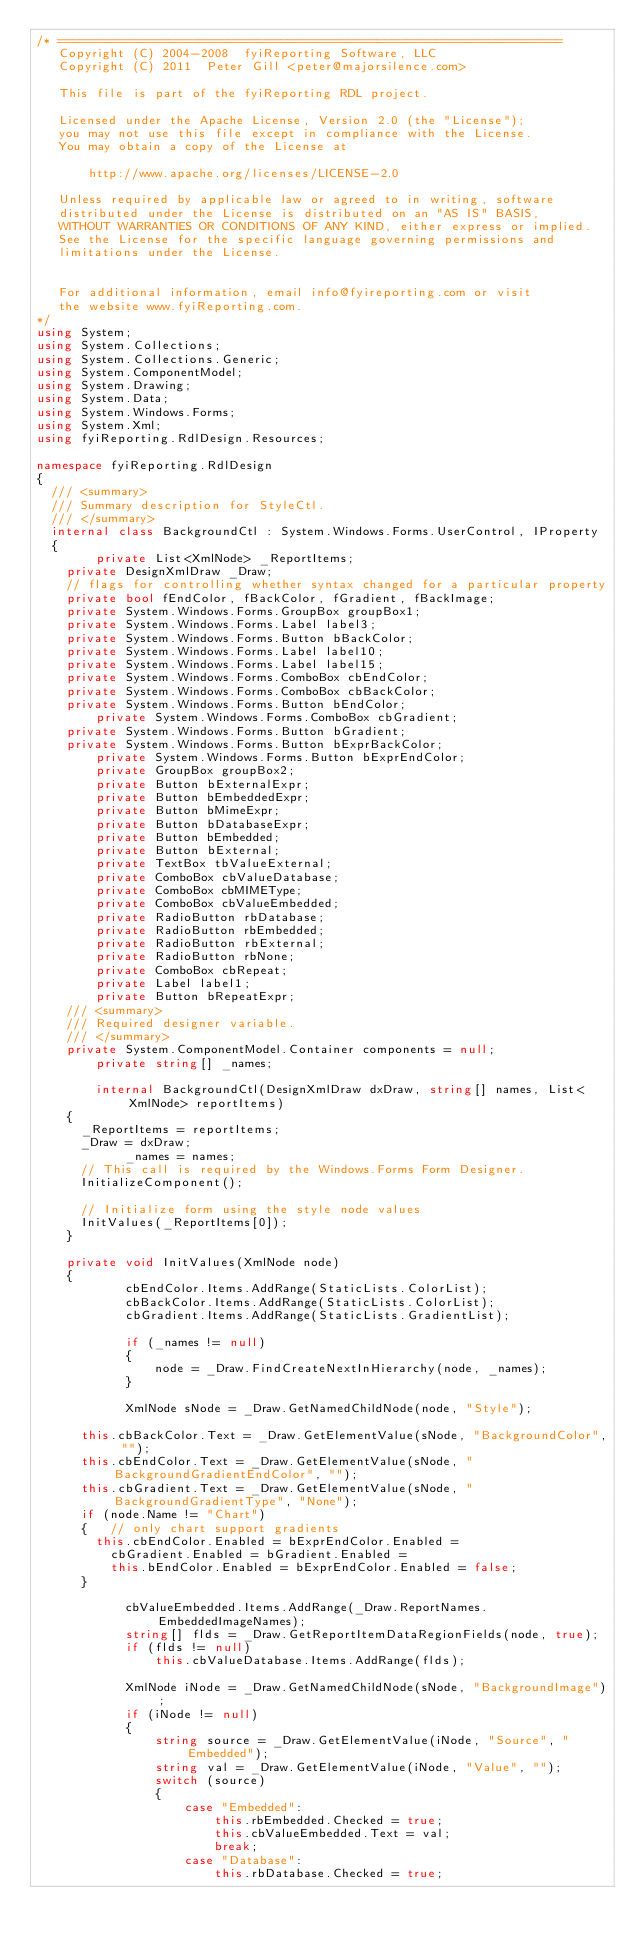<code> <loc_0><loc_0><loc_500><loc_500><_C#_>/* ====================================================================
   Copyright (C) 2004-2008  fyiReporting Software, LLC
   Copyright (C) 2011  Peter Gill <peter@majorsilence.com>

   This file is part of the fyiReporting RDL project.
	
   Licensed under the Apache License, Version 2.0 (the "License");
   you may not use this file except in compliance with the License.
   You may obtain a copy of the License at

       http://www.apache.org/licenses/LICENSE-2.0

   Unless required by applicable law or agreed to in writing, software
   distributed under the License is distributed on an "AS IS" BASIS,
   WITHOUT WARRANTIES OR CONDITIONS OF ANY KIND, either express or implied.
   See the License for the specific language governing permissions and
   limitations under the License.


   For additional information, email info@fyireporting.com or visit
   the website www.fyiReporting.com.
*/
using System;
using System.Collections;
using System.Collections.Generic;
using System.ComponentModel;
using System.Drawing;
using System.Data;
using System.Windows.Forms;
using System.Xml;
using fyiReporting.RdlDesign.Resources;

namespace fyiReporting.RdlDesign
{
	/// <summary>
	/// Summary description for StyleCtl.
	/// </summary>
	internal class BackgroundCtl : System.Windows.Forms.UserControl, IProperty
	{
        private List<XmlNode> _ReportItems;
		private DesignXmlDraw _Draw;
		// flags for controlling whether syntax changed for a particular property
		private bool fEndColor, fBackColor, fGradient, fBackImage;
		private System.Windows.Forms.GroupBox groupBox1;
		private System.Windows.Forms.Label label3;
		private System.Windows.Forms.Button bBackColor;
		private System.Windows.Forms.Label label10;
		private System.Windows.Forms.Label label15;
		private System.Windows.Forms.ComboBox cbEndColor;
		private System.Windows.Forms.ComboBox cbBackColor;
		private System.Windows.Forms.Button bEndColor;
        private System.Windows.Forms.ComboBox cbGradient;
		private System.Windows.Forms.Button bGradient;
		private System.Windows.Forms.Button bExprBackColor;
        private System.Windows.Forms.Button bExprEndColor;
        private GroupBox groupBox2;
        private Button bExternalExpr;
        private Button bEmbeddedExpr;
        private Button bMimeExpr;
        private Button bDatabaseExpr;
        private Button bEmbedded;
        private Button bExternal;
        private TextBox tbValueExternal;
        private ComboBox cbValueDatabase;
        private ComboBox cbMIMEType;
        private ComboBox cbValueEmbedded;
        private RadioButton rbDatabase;
        private RadioButton rbEmbedded;
        private RadioButton rbExternal;
        private RadioButton rbNone;
        private ComboBox cbRepeat;
        private Label label1;
        private Button bRepeatExpr;
		/// <summary> 
		/// Required designer variable.
		/// </summary>
		private System.ComponentModel.Container components = null;
        private string[] _names;

        internal BackgroundCtl(DesignXmlDraw dxDraw, string[] names, List<XmlNode> reportItems)
		{
			_ReportItems = reportItems;
			_Draw = dxDraw;
            _names = names;
			// This call is required by the Windows.Forms Form Designer.
			InitializeComponent();

			// Initialize form using the style node values
			InitValues(_ReportItems[0]);			
		}

		private void InitValues(XmlNode node)
		{
            cbEndColor.Items.AddRange(StaticLists.ColorList);
            cbBackColor.Items.AddRange(StaticLists.ColorList);
            cbGradient.Items.AddRange(StaticLists.GradientList);

            if (_names != null)
            {
                node = _Draw.FindCreateNextInHierarchy(node, _names);
            }

            XmlNode sNode = _Draw.GetNamedChildNode(node, "Style");

			this.cbBackColor.Text = _Draw.GetElementValue(sNode, "BackgroundColor", "");
			this.cbEndColor.Text = _Draw.GetElementValue(sNode, "BackgroundGradientEndColor", "");
			this.cbGradient.Text = _Draw.GetElementValue(sNode, "BackgroundGradientType", "None");
			if (node.Name != "Chart")
			{   // only chart support gradients
				this.cbEndColor.Enabled = bExprEndColor.Enabled =
					cbGradient.Enabled = bGradient.Enabled = 
					this.bEndColor.Enabled = bExprEndColor.Enabled = false;
			}

            cbValueEmbedded.Items.AddRange(_Draw.ReportNames.EmbeddedImageNames);
            string[] flds = _Draw.GetReportItemDataRegionFields(node, true);
            if (flds != null)
                this.cbValueDatabase.Items.AddRange(flds);

            XmlNode iNode = _Draw.GetNamedChildNode(sNode, "BackgroundImage");
            if (iNode != null)
            {
                string source = _Draw.GetElementValue(iNode, "Source", "Embedded");
                string val = _Draw.GetElementValue(iNode, "Value", "");
                switch (source)
                {
                    case "Embedded":
                        this.rbEmbedded.Checked = true;
                        this.cbValueEmbedded.Text = val;
                        break;
                    case "Database":
                        this.rbDatabase.Checked = true;</code> 